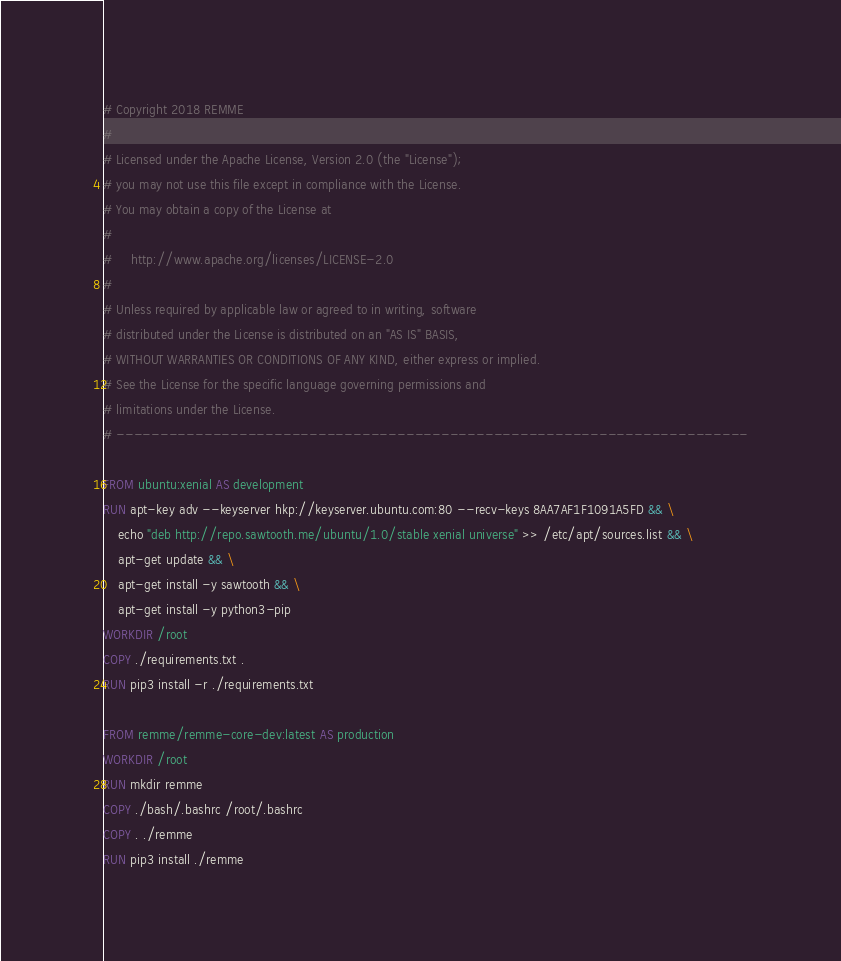<code> <loc_0><loc_0><loc_500><loc_500><_Dockerfile_># Copyright 2018 REMME
#
# Licensed under the Apache License, Version 2.0 (the "License");
# you may not use this file except in compliance with the License.
# You may obtain a copy of the License at
#
#     http://www.apache.org/licenses/LICENSE-2.0
#
# Unless required by applicable law or agreed to in writing, software
# distributed under the License is distributed on an "AS IS" BASIS,
# WITHOUT WARRANTIES OR CONDITIONS OF ANY KIND, either express or implied.
# See the License for the specific language governing permissions and
# limitations under the License.
# ------------------------------------------------------------------------

FROM ubuntu:xenial AS development
RUN apt-key adv --keyserver hkp://keyserver.ubuntu.com:80 --recv-keys 8AA7AF1F1091A5FD && \
    echo "deb http://repo.sawtooth.me/ubuntu/1.0/stable xenial universe" >> /etc/apt/sources.list && \
    apt-get update && \
    apt-get install -y sawtooth && \
    apt-get install -y python3-pip
WORKDIR /root
COPY ./requirements.txt .
RUN pip3 install -r ./requirements.txt

FROM remme/remme-core-dev:latest AS production
WORKDIR /root
RUN mkdir remme
COPY ./bash/.bashrc /root/.bashrc
COPY . ./remme
RUN pip3 install ./remme
</code> 